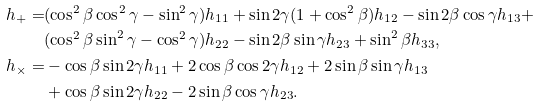Convert formula to latex. <formula><loc_0><loc_0><loc_500><loc_500>h _ { + } = & ( \cos ^ { 2 } \beta \cos ^ { 2 } \gamma - \sin ^ { 2 } \gamma ) h _ { 1 1 } + \sin 2 \gamma ( 1 + \cos ^ { 2 } \beta ) h _ { 1 2 } - \sin 2 \beta \cos \gamma h _ { 1 3 } + \\ & ( \cos ^ { 2 } \beta \sin ^ { 2 } \gamma - \cos ^ { 2 } \gamma ) h _ { 2 2 } - \sin 2 \beta \sin \gamma h _ { 2 3 } + \sin ^ { 2 } \beta h _ { 3 3 } , \\ h _ { \times } = & - \cos \beta \sin 2 \gamma h _ { 1 1 } + 2 \cos \beta \cos 2 \gamma h _ { 1 2 } + 2 \sin \beta \sin \gamma h _ { 1 3 } \\ & + \cos \beta \sin 2 \gamma h _ { 2 2 } - 2 \sin \beta \cos \gamma h _ { 2 3 } .</formula> 